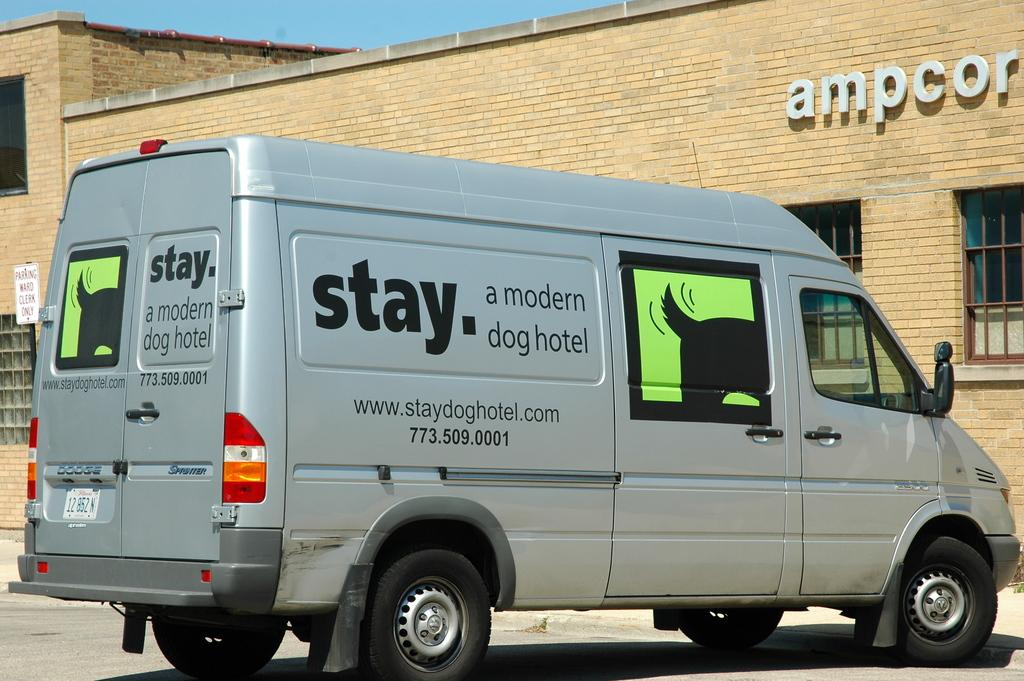<image>
Give a short and clear explanation of the subsequent image. Silver van which says "a modern dog hotel" on it. 